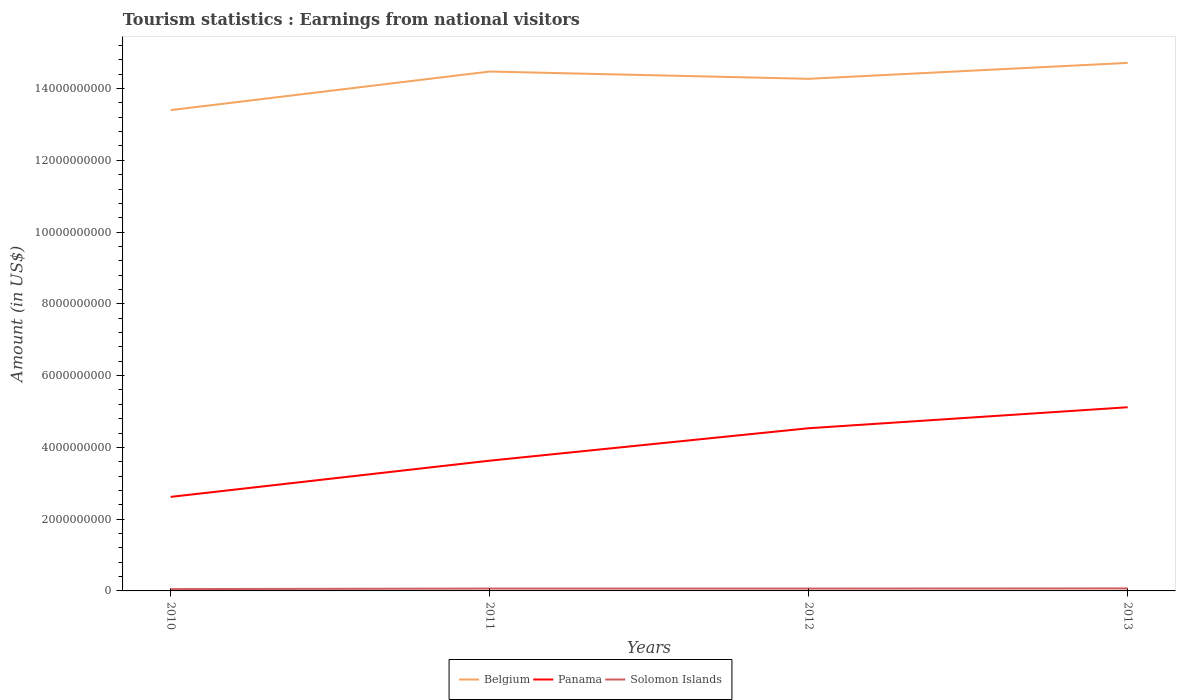Does the line corresponding to Solomon Islands intersect with the line corresponding to Panama?
Your response must be concise. No. Across all years, what is the maximum earnings from national visitors in Panama?
Your answer should be very brief. 2.62e+09. In which year was the earnings from national visitors in Panama maximum?
Keep it short and to the point. 2010. What is the total earnings from national visitors in Panama in the graph?
Offer a terse response. -1.01e+09. What is the difference between the highest and the second highest earnings from national visitors in Solomon Islands?
Make the answer very short. 1.88e+07. What is the difference between the highest and the lowest earnings from national visitors in Belgium?
Make the answer very short. 3. How many lines are there?
Provide a succinct answer. 3. How many years are there in the graph?
Provide a succinct answer. 4. What is the difference between two consecutive major ticks on the Y-axis?
Keep it short and to the point. 2.00e+09. Does the graph contain any zero values?
Keep it short and to the point. No. Does the graph contain grids?
Offer a very short reply. No. Where does the legend appear in the graph?
Offer a terse response. Bottom center. What is the title of the graph?
Give a very brief answer. Tourism statistics : Earnings from national visitors. Does "Norway" appear as one of the legend labels in the graph?
Provide a short and direct response. No. What is the label or title of the X-axis?
Your answer should be compact. Years. What is the label or title of the Y-axis?
Your response must be concise. Amount (in US$). What is the Amount (in US$) in Belgium in 2010?
Make the answer very short. 1.34e+1. What is the Amount (in US$) in Panama in 2010?
Your answer should be compact. 2.62e+09. What is the Amount (in US$) in Solomon Islands in 2010?
Your answer should be very brief. 5.08e+07. What is the Amount (in US$) in Belgium in 2011?
Keep it short and to the point. 1.45e+1. What is the Amount (in US$) in Panama in 2011?
Offer a terse response. 3.63e+09. What is the Amount (in US$) in Solomon Islands in 2011?
Offer a terse response. 6.59e+07. What is the Amount (in US$) in Belgium in 2012?
Make the answer very short. 1.43e+1. What is the Amount (in US$) in Panama in 2012?
Give a very brief answer. 4.53e+09. What is the Amount (in US$) in Solomon Islands in 2012?
Ensure brevity in your answer.  6.54e+07. What is the Amount (in US$) of Belgium in 2013?
Keep it short and to the point. 1.47e+1. What is the Amount (in US$) of Panama in 2013?
Give a very brief answer. 5.12e+09. What is the Amount (in US$) of Solomon Islands in 2013?
Your answer should be very brief. 6.96e+07. Across all years, what is the maximum Amount (in US$) of Belgium?
Keep it short and to the point. 1.47e+1. Across all years, what is the maximum Amount (in US$) of Panama?
Give a very brief answer. 5.12e+09. Across all years, what is the maximum Amount (in US$) of Solomon Islands?
Provide a short and direct response. 6.96e+07. Across all years, what is the minimum Amount (in US$) of Belgium?
Keep it short and to the point. 1.34e+1. Across all years, what is the minimum Amount (in US$) in Panama?
Keep it short and to the point. 2.62e+09. Across all years, what is the minimum Amount (in US$) in Solomon Islands?
Ensure brevity in your answer.  5.08e+07. What is the total Amount (in US$) of Belgium in the graph?
Make the answer very short. 5.69e+1. What is the total Amount (in US$) of Panama in the graph?
Keep it short and to the point. 1.59e+1. What is the total Amount (in US$) in Solomon Islands in the graph?
Keep it short and to the point. 2.52e+08. What is the difference between the Amount (in US$) of Belgium in 2010 and that in 2011?
Give a very brief answer. -1.08e+09. What is the difference between the Amount (in US$) in Panama in 2010 and that in 2011?
Ensure brevity in your answer.  -1.01e+09. What is the difference between the Amount (in US$) in Solomon Islands in 2010 and that in 2011?
Your response must be concise. -1.51e+07. What is the difference between the Amount (in US$) of Belgium in 2010 and that in 2012?
Give a very brief answer. -8.72e+08. What is the difference between the Amount (in US$) in Panama in 2010 and that in 2012?
Give a very brief answer. -1.91e+09. What is the difference between the Amount (in US$) in Solomon Islands in 2010 and that in 2012?
Offer a terse response. -1.46e+07. What is the difference between the Amount (in US$) in Belgium in 2010 and that in 2013?
Your answer should be very brief. -1.32e+09. What is the difference between the Amount (in US$) in Panama in 2010 and that in 2013?
Ensure brevity in your answer.  -2.50e+09. What is the difference between the Amount (in US$) in Solomon Islands in 2010 and that in 2013?
Keep it short and to the point. -1.88e+07. What is the difference between the Amount (in US$) of Belgium in 2011 and that in 2012?
Provide a short and direct response. 2.03e+08. What is the difference between the Amount (in US$) of Panama in 2011 and that in 2012?
Ensure brevity in your answer.  -9.04e+08. What is the difference between the Amount (in US$) of Belgium in 2011 and that in 2013?
Provide a short and direct response. -2.41e+08. What is the difference between the Amount (in US$) in Panama in 2011 and that in 2013?
Provide a succinct answer. -1.49e+09. What is the difference between the Amount (in US$) of Solomon Islands in 2011 and that in 2013?
Your answer should be very brief. -3.70e+06. What is the difference between the Amount (in US$) in Belgium in 2012 and that in 2013?
Your answer should be compact. -4.44e+08. What is the difference between the Amount (in US$) in Panama in 2012 and that in 2013?
Your answer should be very brief. -5.85e+08. What is the difference between the Amount (in US$) of Solomon Islands in 2012 and that in 2013?
Keep it short and to the point. -4.20e+06. What is the difference between the Amount (in US$) of Belgium in 2010 and the Amount (in US$) of Panama in 2011?
Your response must be concise. 9.77e+09. What is the difference between the Amount (in US$) of Belgium in 2010 and the Amount (in US$) of Solomon Islands in 2011?
Provide a short and direct response. 1.33e+1. What is the difference between the Amount (in US$) in Panama in 2010 and the Amount (in US$) in Solomon Islands in 2011?
Provide a short and direct response. 2.56e+09. What is the difference between the Amount (in US$) of Belgium in 2010 and the Amount (in US$) of Panama in 2012?
Offer a terse response. 8.87e+09. What is the difference between the Amount (in US$) of Belgium in 2010 and the Amount (in US$) of Solomon Islands in 2012?
Your answer should be very brief. 1.33e+1. What is the difference between the Amount (in US$) of Panama in 2010 and the Amount (in US$) of Solomon Islands in 2012?
Your answer should be compact. 2.56e+09. What is the difference between the Amount (in US$) of Belgium in 2010 and the Amount (in US$) of Panama in 2013?
Make the answer very short. 8.28e+09. What is the difference between the Amount (in US$) in Belgium in 2010 and the Amount (in US$) in Solomon Islands in 2013?
Offer a very short reply. 1.33e+1. What is the difference between the Amount (in US$) in Panama in 2010 and the Amount (in US$) in Solomon Islands in 2013?
Provide a succinct answer. 2.55e+09. What is the difference between the Amount (in US$) of Belgium in 2011 and the Amount (in US$) of Panama in 2012?
Give a very brief answer. 9.94e+09. What is the difference between the Amount (in US$) in Belgium in 2011 and the Amount (in US$) in Solomon Islands in 2012?
Your answer should be very brief. 1.44e+1. What is the difference between the Amount (in US$) in Panama in 2011 and the Amount (in US$) in Solomon Islands in 2012?
Your answer should be very brief. 3.56e+09. What is the difference between the Amount (in US$) of Belgium in 2011 and the Amount (in US$) of Panama in 2013?
Give a very brief answer. 9.36e+09. What is the difference between the Amount (in US$) in Belgium in 2011 and the Amount (in US$) in Solomon Islands in 2013?
Your answer should be compact. 1.44e+1. What is the difference between the Amount (in US$) in Panama in 2011 and the Amount (in US$) in Solomon Islands in 2013?
Offer a terse response. 3.56e+09. What is the difference between the Amount (in US$) of Belgium in 2012 and the Amount (in US$) of Panama in 2013?
Ensure brevity in your answer.  9.15e+09. What is the difference between the Amount (in US$) in Belgium in 2012 and the Amount (in US$) in Solomon Islands in 2013?
Make the answer very short. 1.42e+1. What is the difference between the Amount (in US$) of Panama in 2012 and the Amount (in US$) of Solomon Islands in 2013?
Your response must be concise. 4.46e+09. What is the average Amount (in US$) in Belgium per year?
Make the answer very short. 1.42e+1. What is the average Amount (in US$) of Panama per year?
Keep it short and to the point. 3.98e+09. What is the average Amount (in US$) in Solomon Islands per year?
Your answer should be very brief. 6.29e+07. In the year 2010, what is the difference between the Amount (in US$) in Belgium and Amount (in US$) in Panama?
Your answer should be very brief. 1.08e+1. In the year 2010, what is the difference between the Amount (in US$) in Belgium and Amount (in US$) in Solomon Islands?
Your answer should be very brief. 1.33e+1. In the year 2010, what is the difference between the Amount (in US$) in Panama and Amount (in US$) in Solomon Islands?
Ensure brevity in your answer.  2.57e+09. In the year 2011, what is the difference between the Amount (in US$) of Belgium and Amount (in US$) of Panama?
Keep it short and to the point. 1.08e+1. In the year 2011, what is the difference between the Amount (in US$) of Belgium and Amount (in US$) of Solomon Islands?
Offer a very short reply. 1.44e+1. In the year 2011, what is the difference between the Amount (in US$) in Panama and Amount (in US$) in Solomon Islands?
Your response must be concise. 3.56e+09. In the year 2012, what is the difference between the Amount (in US$) in Belgium and Amount (in US$) in Panama?
Offer a very short reply. 9.74e+09. In the year 2012, what is the difference between the Amount (in US$) in Belgium and Amount (in US$) in Solomon Islands?
Give a very brief answer. 1.42e+1. In the year 2012, what is the difference between the Amount (in US$) of Panama and Amount (in US$) of Solomon Islands?
Keep it short and to the point. 4.47e+09. In the year 2013, what is the difference between the Amount (in US$) in Belgium and Amount (in US$) in Panama?
Offer a very short reply. 9.60e+09. In the year 2013, what is the difference between the Amount (in US$) of Belgium and Amount (in US$) of Solomon Islands?
Your answer should be very brief. 1.46e+1. In the year 2013, what is the difference between the Amount (in US$) in Panama and Amount (in US$) in Solomon Islands?
Your answer should be compact. 5.05e+09. What is the ratio of the Amount (in US$) in Belgium in 2010 to that in 2011?
Provide a short and direct response. 0.93. What is the ratio of the Amount (in US$) in Panama in 2010 to that in 2011?
Your answer should be compact. 0.72. What is the ratio of the Amount (in US$) in Solomon Islands in 2010 to that in 2011?
Provide a short and direct response. 0.77. What is the ratio of the Amount (in US$) in Belgium in 2010 to that in 2012?
Your answer should be very brief. 0.94. What is the ratio of the Amount (in US$) of Panama in 2010 to that in 2012?
Provide a short and direct response. 0.58. What is the ratio of the Amount (in US$) of Solomon Islands in 2010 to that in 2012?
Your answer should be compact. 0.78. What is the ratio of the Amount (in US$) of Belgium in 2010 to that in 2013?
Provide a short and direct response. 0.91. What is the ratio of the Amount (in US$) of Panama in 2010 to that in 2013?
Make the answer very short. 0.51. What is the ratio of the Amount (in US$) in Solomon Islands in 2010 to that in 2013?
Offer a very short reply. 0.73. What is the ratio of the Amount (in US$) of Belgium in 2011 to that in 2012?
Ensure brevity in your answer.  1.01. What is the ratio of the Amount (in US$) of Panama in 2011 to that in 2012?
Your response must be concise. 0.8. What is the ratio of the Amount (in US$) of Solomon Islands in 2011 to that in 2012?
Your answer should be compact. 1.01. What is the ratio of the Amount (in US$) of Belgium in 2011 to that in 2013?
Make the answer very short. 0.98. What is the ratio of the Amount (in US$) of Panama in 2011 to that in 2013?
Provide a short and direct response. 0.71. What is the ratio of the Amount (in US$) of Solomon Islands in 2011 to that in 2013?
Offer a very short reply. 0.95. What is the ratio of the Amount (in US$) of Belgium in 2012 to that in 2013?
Your answer should be very brief. 0.97. What is the ratio of the Amount (in US$) of Panama in 2012 to that in 2013?
Your answer should be very brief. 0.89. What is the ratio of the Amount (in US$) in Solomon Islands in 2012 to that in 2013?
Keep it short and to the point. 0.94. What is the difference between the highest and the second highest Amount (in US$) in Belgium?
Keep it short and to the point. 2.41e+08. What is the difference between the highest and the second highest Amount (in US$) in Panama?
Provide a succinct answer. 5.85e+08. What is the difference between the highest and the second highest Amount (in US$) of Solomon Islands?
Your answer should be very brief. 3.70e+06. What is the difference between the highest and the lowest Amount (in US$) in Belgium?
Offer a very short reply. 1.32e+09. What is the difference between the highest and the lowest Amount (in US$) in Panama?
Offer a very short reply. 2.50e+09. What is the difference between the highest and the lowest Amount (in US$) of Solomon Islands?
Provide a short and direct response. 1.88e+07. 